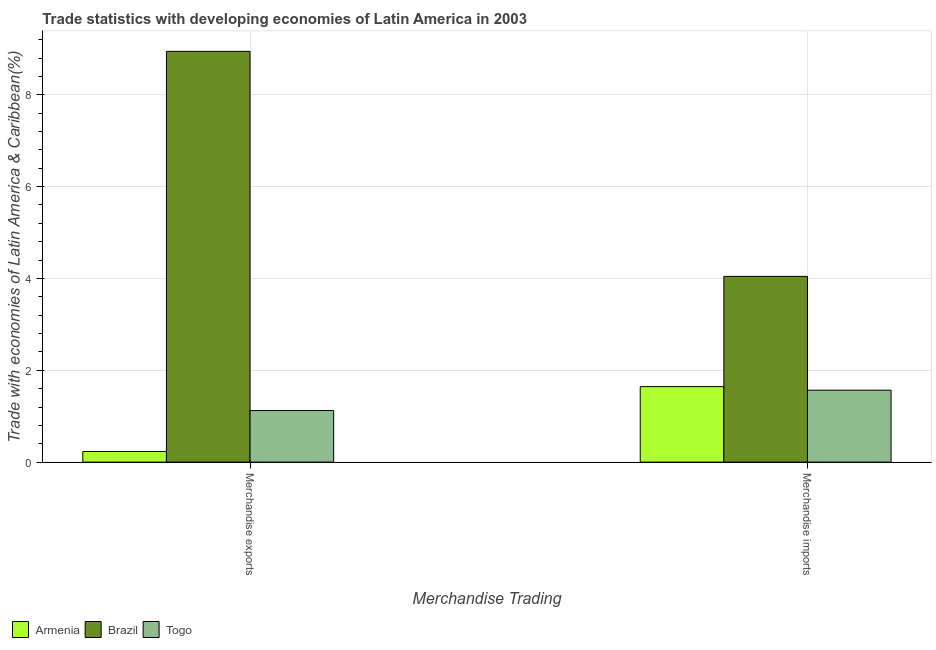How many different coloured bars are there?
Offer a terse response. 3. Are the number of bars per tick equal to the number of legend labels?
Give a very brief answer. Yes. Are the number of bars on each tick of the X-axis equal?
Your answer should be very brief. Yes. How many bars are there on the 1st tick from the left?
Offer a terse response. 3. How many bars are there on the 2nd tick from the right?
Your answer should be very brief. 3. What is the label of the 1st group of bars from the left?
Provide a succinct answer. Merchandise exports. What is the merchandise exports in Togo?
Ensure brevity in your answer.  1.12. Across all countries, what is the maximum merchandise exports?
Your answer should be very brief. 8.94. Across all countries, what is the minimum merchandise exports?
Offer a terse response. 0.23. In which country was the merchandise exports maximum?
Ensure brevity in your answer.  Brazil. In which country was the merchandise imports minimum?
Provide a short and direct response. Togo. What is the total merchandise exports in the graph?
Your answer should be compact. 10.3. What is the difference between the merchandise exports in Brazil and that in Armenia?
Make the answer very short. 8.71. What is the difference between the merchandise exports in Brazil and the merchandise imports in Armenia?
Your answer should be compact. 7.3. What is the average merchandise exports per country?
Offer a very short reply. 3.43. What is the difference between the merchandise exports and merchandise imports in Brazil?
Your response must be concise. 4.9. What is the ratio of the merchandise imports in Brazil to that in Togo?
Ensure brevity in your answer.  2.58. Is the merchandise exports in Brazil less than that in Togo?
Offer a terse response. No. In how many countries, is the merchandise imports greater than the average merchandise imports taken over all countries?
Offer a terse response. 1. What does the 1st bar from the right in Merchandise exports represents?
Provide a short and direct response. Togo. How many countries are there in the graph?
Offer a terse response. 3. Does the graph contain any zero values?
Give a very brief answer. No. Does the graph contain grids?
Make the answer very short. Yes. Where does the legend appear in the graph?
Provide a succinct answer. Bottom left. How many legend labels are there?
Ensure brevity in your answer.  3. What is the title of the graph?
Offer a very short reply. Trade statistics with developing economies of Latin America in 2003. What is the label or title of the X-axis?
Offer a terse response. Merchandise Trading. What is the label or title of the Y-axis?
Provide a succinct answer. Trade with economies of Latin America & Caribbean(%). What is the Trade with economies of Latin America & Caribbean(%) in Armenia in Merchandise exports?
Keep it short and to the point. 0.23. What is the Trade with economies of Latin America & Caribbean(%) in Brazil in Merchandise exports?
Your answer should be very brief. 8.94. What is the Trade with economies of Latin America & Caribbean(%) of Togo in Merchandise exports?
Your answer should be very brief. 1.12. What is the Trade with economies of Latin America & Caribbean(%) in Armenia in Merchandise imports?
Your response must be concise. 1.64. What is the Trade with economies of Latin America & Caribbean(%) in Brazil in Merchandise imports?
Keep it short and to the point. 4.04. What is the Trade with economies of Latin America & Caribbean(%) of Togo in Merchandise imports?
Provide a succinct answer. 1.57. Across all Merchandise Trading, what is the maximum Trade with economies of Latin America & Caribbean(%) of Armenia?
Offer a very short reply. 1.64. Across all Merchandise Trading, what is the maximum Trade with economies of Latin America & Caribbean(%) of Brazil?
Give a very brief answer. 8.94. Across all Merchandise Trading, what is the maximum Trade with economies of Latin America & Caribbean(%) of Togo?
Your response must be concise. 1.57. Across all Merchandise Trading, what is the minimum Trade with economies of Latin America & Caribbean(%) in Armenia?
Make the answer very short. 0.23. Across all Merchandise Trading, what is the minimum Trade with economies of Latin America & Caribbean(%) of Brazil?
Make the answer very short. 4.04. Across all Merchandise Trading, what is the minimum Trade with economies of Latin America & Caribbean(%) of Togo?
Make the answer very short. 1.12. What is the total Trade with economies of Latin America & Caribbean(%) in Armenia in the graph?
Give a very brief answer. 1.88. What is the total Trade with economies of Latin America & Caribbean(%) in Brazil in the graph?
Offer a very short reply. 12.99. What is the total Trade with economies of Latin America & Caribbean(%) of Togo in the graph?
Ensure brevity in your answer.  2.69. What is the difference between the Trade with economies of Latin America & Caribbean(%) in Armenia in Merchandise exports and that in Merchandise imports?
Your response must be concise. -1.41. What is the difference between the Trade with economies of Latin America & Caribbean(%) in Brazil in Merchandise exports and that in Merchandise imports?
Ensure brevity in your answer.  4.9. What is the difference between the Trade with economies of Latin America & Caribbean(%) in Togo in Merchandise exports and that in Merchandise imports?
Your response must be concise. -0.44. What is the difference between the Trade with economies of Latin America & Caribbean(%) of Armenia in Merchandise exports and the Trade with economies of Latin America & Caribbean(%) of Brazil in Merchandise imports?
Provide a short and direct response. -3.81. What is the difference between the Trade with economies of Latin America & Caribbean(%) in Armenia in Merchandise exports and the Trade with economies of Latin America & Caribbean(%) in Togo in Merchandise imports?
Ensure brevity in your answer.  -1.34. What is the difference between the Trade with economies of Latin America & Caribbean(%) in Brazil in Merchandise exports and the Trade with economies of Latin America & Caribbean(%) in Togo in Merchandise imports?
Ensure brevity in your answer.  7.38. What is the average Trade with economies of Latin America & Caribbean(%) of Armenia per Merchandise Trading?
Keep it short and to the point. 0.94. What is the average Trade with economies of Latin America & Caribbean(%) of Brazil per Merchandise Trading?
Your answer should be compact. 6.49. What is the average Trade with economies of Latin America & Caribbean(%) of Togo per Merchandise Trading?
Your answer should be very brief. 1.34. What is the difference between the Trade with economies of Latin America & Caribbean(%) in Armenia and Trade with economies of Latin America & Caribbean(%) in Brazil in Merchandise exports?
Provide a short and direct response. -8.71. What is the difference between the Trade with economies of Latin America & Caribbean(%) of Armenia and Trade with economies of Latin America & Caribbean(%) of Togo in Merchandise exports?
Your response must be concise. -0.89. What is the difference between the Trade with economies of Latin America & Caribbean(%) in Brazil and Trade with economies of Latin America & Caribbean(%) in Togo in Merchandise exports?
Your answer should be very brief. 7.82. What is the difference between the Trade with economies of Latin America & Caribbean(%) in Armenia and Trade with economies of Latin America & Caribbean(%) in Brazil in Merchandise imports?
Give a very brief answer. -2.4. What is the difference between the Trade with economies of Latin America & Caribbean(%) in Armenia and Trade with economies of Latin America & Caribbean(%) in Togo in Merchandise imports?
Make the answer very short. 0.08. What is the difference between the Trade with economies of Latin America & Caribbean(%) in Brazil and Trade with economies of Latin America & Caribbean(%) in Togo in Merchandise imports?
Your answer should be compact. 2.48. What is the ratio of the Trade with economies of Latin America & Caribbean(%) in Armenia in Merchandise exports to that in Merchandise imports?
Offer a terse response. 0.14. What is the ratio of the Trade with economies of Latin America & Caribbean(%) in Brazil in Merchandise exports to that in Merchandise imports?
Make the answer very short. 2.21. What is the ratio of the Trade with economies of Latin America & Caribbean(%) of Togo in Merchandise exports to that in Merchandise imports?
Your response must be concise. 0.72. What is the difference between the highest and the second highest Trade with economies of Latin America & Caribbean(%) in Armenia?
Make the answer very short. 1.41. What is the difference between the highest and the second highest Trade with economies of Latin America & Caribbean(%) of Brazil?
Your answer should be very brief. 4.9. What is the difference between the highest and the second highest Trade with economies of Latin America & Caribbean(%) of Togo?
Provide a short and direct response. 0.44. What is the difference between the highest and the lowest Trade with economies of Latin America & Caribbean(%) of Armenia?
Your answer should be compact. 1.41. What is the difference between the highest and the lowest Trade with economies of Latin America & Caribbean(%) of Brazil?
Provide a short and direct response. 4.9. What is the difference between the highest and the lowest Trade with economies of Latin America & Caribbean(%) of Togo?
Make the answer very short. 0.44. 